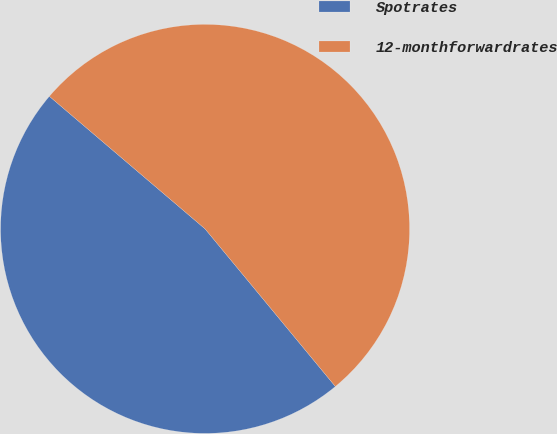Convert chart. <chart><loc_0><loc_0><loc_500><loc_500><pie_chart><fcel>Spotrates<fcel>12-monthforwardrates<nl><fcel>47.22%<fcel>52.78%<nl></chart> 